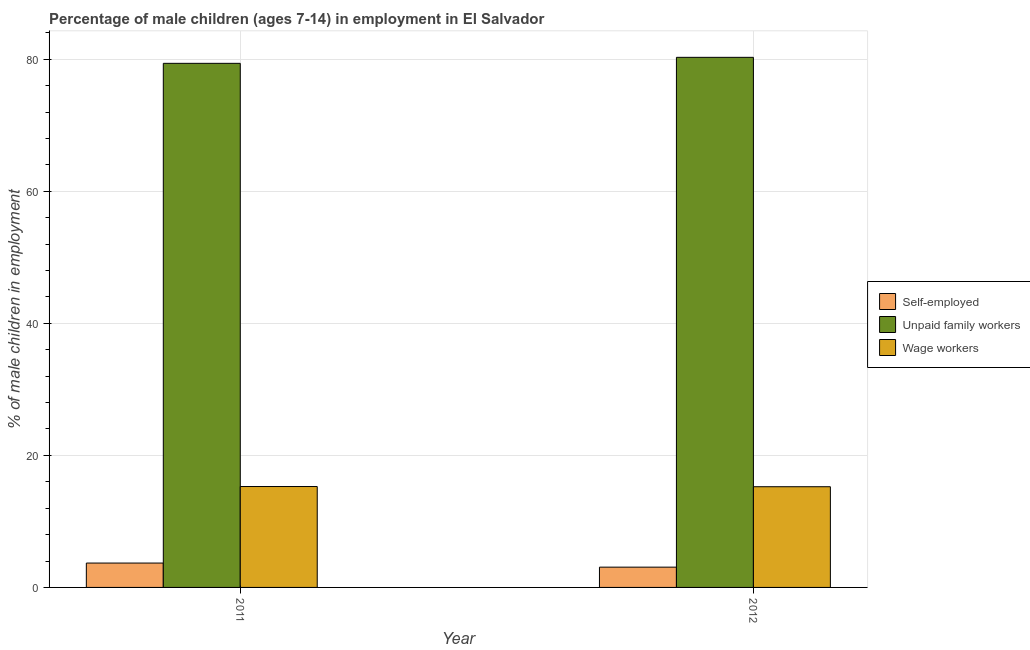How many groups of bars are there?
Your answer should be very brief. 2. Are the number of bars on each tick of the X-axis equal?
Provide a succinct answer. Yes. In how many cases, is the number of bars for a given year not equal to the number of legend labels?
Provide a succinct answer. 0. What is the percentage of self employed children in 2011?
Make the answer very short. 3.69. Across all years, what is the maximum percentage of self employed children?
Your answer should be very brief. 3.69. Across all years, what is the minimum percentage of children employed as wage workers?
Your answer should be compact. 15.25. In which year was the percentage of children employed as wage workers maximum?
Provide a succinct answer. 2011. What is the total percentage of self employed children in the graph?
Offer a very short reply. 6.76. What is the difference between the percentage of self employed children in 2011 and that in 2012?
Your answer should be compact. 0.62. What is the difference between the percentage of children employed as unpaid family workers in 2011 and the percentage of self employed children in 2012?
Provide a short and direct response. -0.91. What is the average percentage of children employed as unpaid family workers per year?
Provide a short and direct response. 79.83. In how many years, is the percentage of self employed children greater than 80 %?
Your response must be concise. 0. What is the ratio of the percentage of children employed as wage workers in 2011 to that in 2012?
Make the answer very short. 1. Is the percentage of children employed as wage workers in 2011 less than that in 2012?
Provide a short and direct response. No. What does the 1st bar from the left in 2011 represents?
Provide a succinct answer. Self-employed. What does the 1st bar from the right in 2011 represents?
Provide a succinct answer. Wage workers. Is it the case that in every year, the sum of the percentage of self employed children and percentage of children employed as unpaid family workers is greater than the percentage of children employed as wage workers?
Keep it short and to the point. Yes. How many bars are there?
Make the answer very short. 6. Are the values on the major ticks of Y-axis written in scientific E-notation?
Give a very brief answer. No. Does the graph contain grids?
Your answer should be very brief. Yes. How many legend labels are there?
Give a very brief answer. 3. What is the title of the graph?
Ensure brevity in your answer.  Percentage of male children (ages 7-14) in employment in El Salvador. Does "Ireland" appear as one of the legend labels in the graph?
Give a very brief answer. No. What is the label or title of the X-axis?
Your response must be concise. Year. What is the label or title of the Y-axis?
Make the answer very short. % of male children in employment. What is the % of male children in employment of Self-employed in 2011?
Ensure brevity in your answer.  3.69. What is the % of male children in employment of Unpaid family workers in 2011?
Your answer should be compact. 79.37. What is the % of male children in employment of Wage workers in 2011?
Ensure brevity in your answer.  15.28. What is the % of male children in employment of Self-employed in 2012?
Give a very brief answer. 3.07. What is the % of male children in employment of Unpaid family workers in 2012?
Provide a succinct answer. 80.28. What is the % of male children in employment in Wage workers in 2012?
Your answer should be very brief. 15.25. Across all years, what is the maximum % of male children in employment of Self-employed?
Give a very brief answer. 3.69. Across all years, what is the maximum % of male children in employment of Unpaid family workers?
Provide a short and direct response. 80.28. Across all years, what is the maximum % of male children in employment in Wage workers?
Your answer should be very brief. 15.28. Across all years, what is the minimum % of male children in employment in Self-employed?
Offer a very short reply. 3.07. Across all years, what is the minimum % of male children in employment of Unpaid family workers?
Offer a terse response. 79.37. Across all years, what is the minimum % of male children in employment of Wage workers?
Offer a very short reply. 15.25. What is the total % of male children in employment in Self-employed in the graph?
Ensure brevity in your answer.  6.76. What is the total % of male children in employment in Unpaid family workers in the graph?
Make the answer very short. 159.65. What is the total % of male children in employment in Wage workers in the graph?
Keep it short and to the point. 30.53. What is the difference between the % of male children in employment in Self-employed in 2011 and that in 2012?
Ensure brevity in your answer.  0.62. What is the difference between the % of male children in employment of Unpaid family workers in 2011 and that in 2012?
Your answer should be compact. -0.91. What is the difference between the % of male children in employment of Wage workers in 2011 and that in 2012?
Keep it short and to the point. 0.03. What is the difference between the % of male children in employment in Self-employed in 2011 and the % of male children in employment in Unpaid family workers in 2012?
Offer a terse response. -76.59. What is the difference between the % of male children in employment of Self-employed in 2011 and the % of male children in employment of Wage workers in 2012?
Your answer should be compact. -11.56. What is the difference between the % of male children in employment in Unpaid family workers in 2011 and the % of male children in employment in Wage workers in 2012?
Provide a short and direct response. 64.12. What is the average % of male children in employment of Self-employed per year?
Ensure brevity in your answer.  3.38. What is the average % of male children in employment in Unpaid family workers per year?
Provide a succinct answer. 79.83. What is the average % of male children in employment of Wage workers per year?
Provide a short and direct response. 15.27. In the year 2011, what is the difference between the % of male children in employment of Self-employed and % of male children in employment of Unpaid family workers?
Offer a terse response. -75.68. In the year 2011, what is the difference between the % of male children in employment of Self-employed and % of male children in employment of Wage workers?
Your answer should be very brief. -11.59. In the year 2011, what is the difference between the % of male children in employment in Unpaid family workers and % of male children in employment in Wage workers?
Provide a short and direct response. 64.09. In the year 2012, what is the difference between the % of male children in employment in Self-employed and % of male children in employment in Unpaid family workers?
Your answer should be very brief. -77.21. In the year 2012, what is the difference between the % of male children in employment in Self-employed and % of male children in employment in Wage workers?
Provide a short and direct response. -12.18. In the year 2012, what is the difference between the % of male children in employment of Unpaid family workers and % of male children in employment of Wage workers?
Ensure brevity in your answer.  65.03. What is the ratio of the % of male children in employment of Self-employed in 2011 to that in 2012?
Give a very brief answer. 1.2. What is the ratio of the % of male children in employment in Unpaid family workers in 2011 to that in 2012?
Make the answer very short. 0.99. What is the ratio of the % of male children in employment of Wage workers in 2011 to that in 2012?
Provide a short and direct response. 1. What is the difference between the highest and the second highest % of male children in employment of Self-employed?
Provide a succinct answer. 0.62. What is the difference between the highest and the second highest % of male children in employment of Unpaid family workers?
Ensure brevity in your answer.  0.91. What is the difference between the highest and the lowest % of male children in employment in Self-employed?
Offer a terse response. 0.62. What is the difference between the highest and the lowest % of male children in employment of Unpaid family workers?
Your response must be concise. 0.91. 